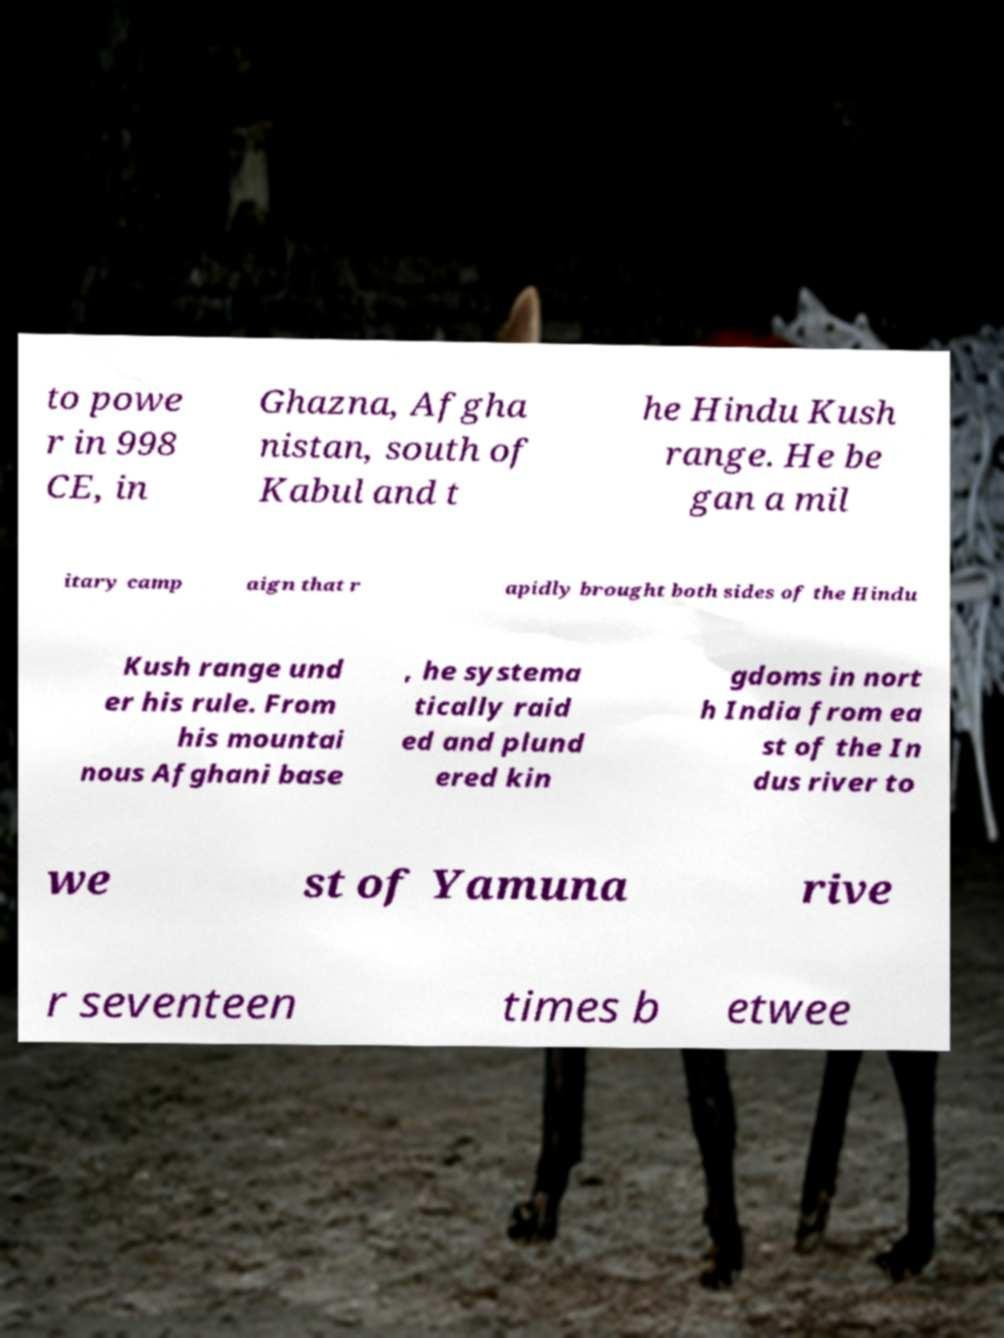I need the written content from this picture converted into text. Can you do that? to powe r in 998 CE, in Ghazna, Afgha nistan, south of Kabul and t he Hindu Kush range. He be gan a mil itary camp aign that r apidly brought both sides of the Hindu Kush range und er his rule. From his mountai nous Afghani base , he systema tically raid ed and plund ered kin gdoms in nort h India from ea st of the In dus river to we st of Yamuna rive r seventeen times b etwee 